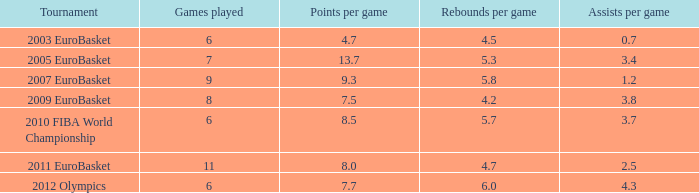How many assists per game in the tournament 2010 fiba world championship? 3.7. 